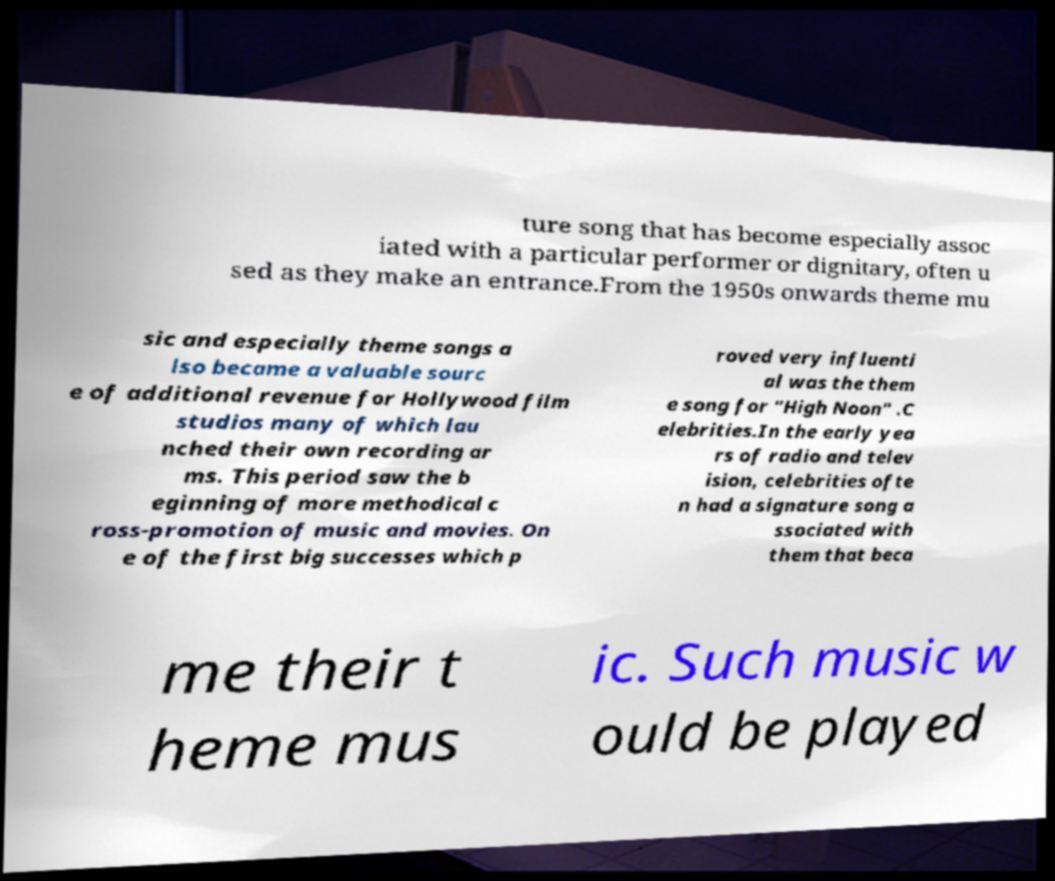Could you extract and type out the text from this image? ture song that has become especially assoc iated with a particular performer or dignitary, often u sed as they make an entrance.From the 1950s onwards theme mu sic and especially theme songs a lso became a valuable sourc e of additional revenue for Hollywood film studios many of which lau nched their own recording ar ms. This period saw the b eginning of more methodical c ross-promotion of music and movies. On e of the first big successes which p roved very influenti al was the them e song for "High Noon" .C elebrities.In the early yea rs of radio and telev ision, celebrities ofte n had a signature song a ssociated with them that beca me their t heme mus ic. Such music w ould be played 